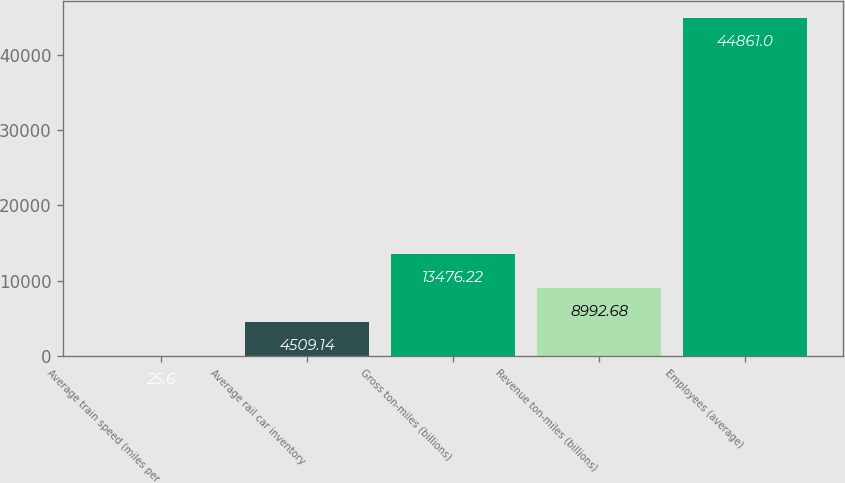<chart> <loc_0><loc_0><loc_500><loc_500><bar_chart><fcel>Average train speed (miles per<fcel>Average rail car inventory<fcel>Gross ton-miles (billions)<fcel>Revenue ton-miles (billions)<fcel>Employees (average)<nl><fcel>25.6<fcel>4509.14<fcel>13476.2<fcel>8992.68<fcel>44861<nl></chart> 